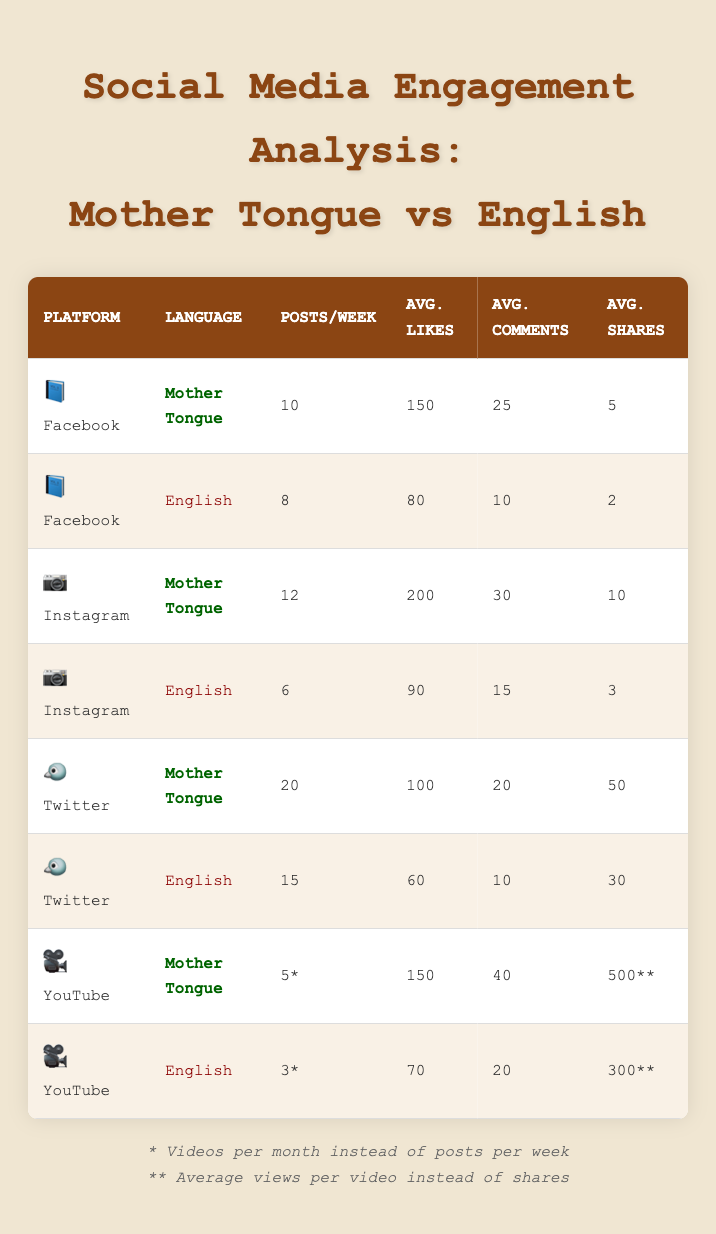What is the average number of likes per post on Facebook for the mother tongue? From the table, the average likes per post for the mother tongue on Facebook is recorded as 150.
Answer: 150 What is the difference in posts per week between mother tongue and English on Instagram? The mother tongue has 12 posts per week on Instagram, while English has 6 posts. The difference is calculated as 12 - 6 = 6.
Answer: 6 Is the average number of likes per video greater for mother tongue or English on YouTube? The average likes for mother tongue is 150 and for English is 70. Since 150 is greater than 70, the result is true.
Answer: Yes What is the total number of tweets per week in both languages combined on Twitter? The mother tongue has 20 tweets per week and English has 15. The total is calculated as 20 + 15 = 35.
Answer: 35 Which platform has the highest average comments per post for the mother tongue? On Facebook, the average comments per post for mother tongue is 25; on Instagram, it is 30; on Twitter, it is 20; and on YouTube, it is 40. Thus, the platform with the highest average comments is YouTube with 40.
Answer: YouTube What is the average number of shares for posts in English on Facebook and Instagram? On Facebook, it is 2 shares and on Instagram 3 shares. The average is calculated as (2 + 3) / 2 = 2.5.
Answer: 2.5 Does the mother tongue have more average views per video than English on YouTube? For mother tongue, the average views are 500 and for English, it is 300. Since 500 is greater than 300, the answer is true.
Answer: Yes What is the average number of likes per tweet for English on Twitter? The average likes per tweet for English is listed as 60 in the table.
Answer: 60 How many more average comments does the mother tongue have compared to English on Instagram? The mother tongue has 30 average comments per post, while English has 15. The difference is 30 - 15 = 15.
Answer: 15 